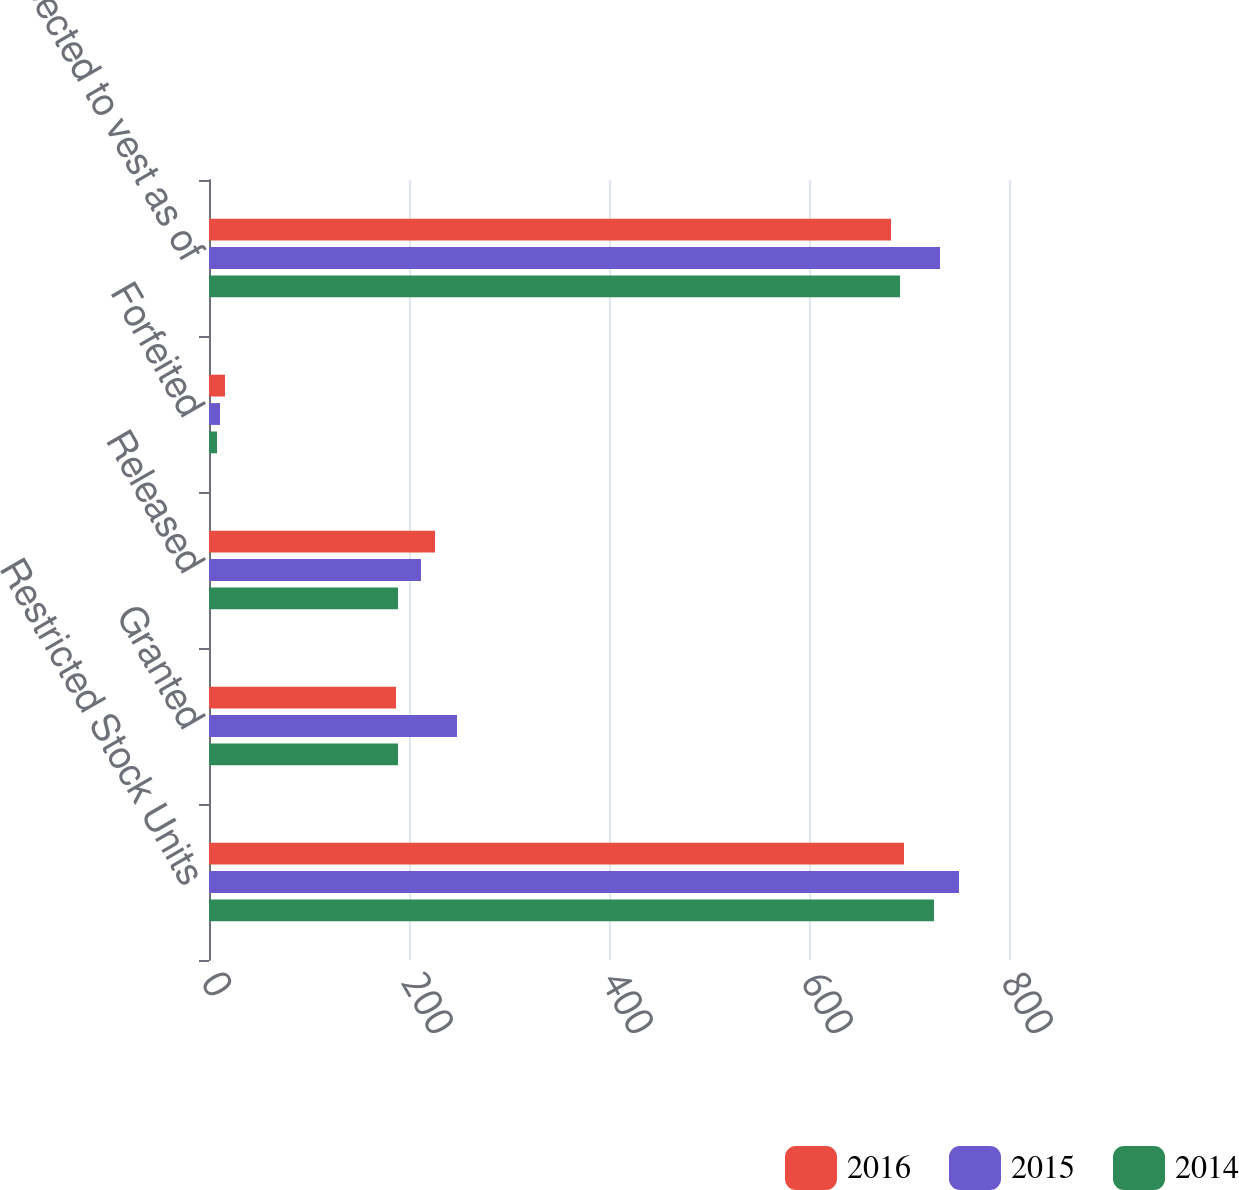Convert chart to OTSL. <chart><loc_0><loc_0><loc_500><loc_500><stacked_bar_chart><ecel><fcel>Restricted Stock Units<fcel>Granted<fcel>Released<fcel>Forfeited<fcel>Expected to vest as of<nl><fcel>2016<fcel>695<fcel>187<fcel>226<fcel>16<fcel>682<nl><fcel>2015<fcel>750<fcel>248<fcel>212<fcel>11<fcel>731<nl><fcel>2014<fcel>725<fcel>189<fcel>189<fcel>8<fcel>691<nl></chart> 